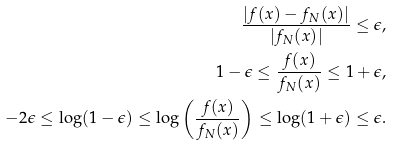Convert formula to latex. <formula><loc_0><loc_0><loc_500><loc_500>\frac { \left | f ( x ) - f _ { N } ( x ) \right | } { \left | f _ { N } ( x ) \right | } \leq \epsilon , \\ 1 - \epsilon \leq \frac { f ( x ) } { f _ { N } ( x ) } \leq 1 + \epsilon , \\ - 2 \epsilon \leq \log ( 1 - \epsilon ) \leq \log \left ( \frac { f ( x ) } { f _ { N } ( x ) } \right ) \leq \log ( 1 + \epsilon ) \leq \epsilon .</formula> 